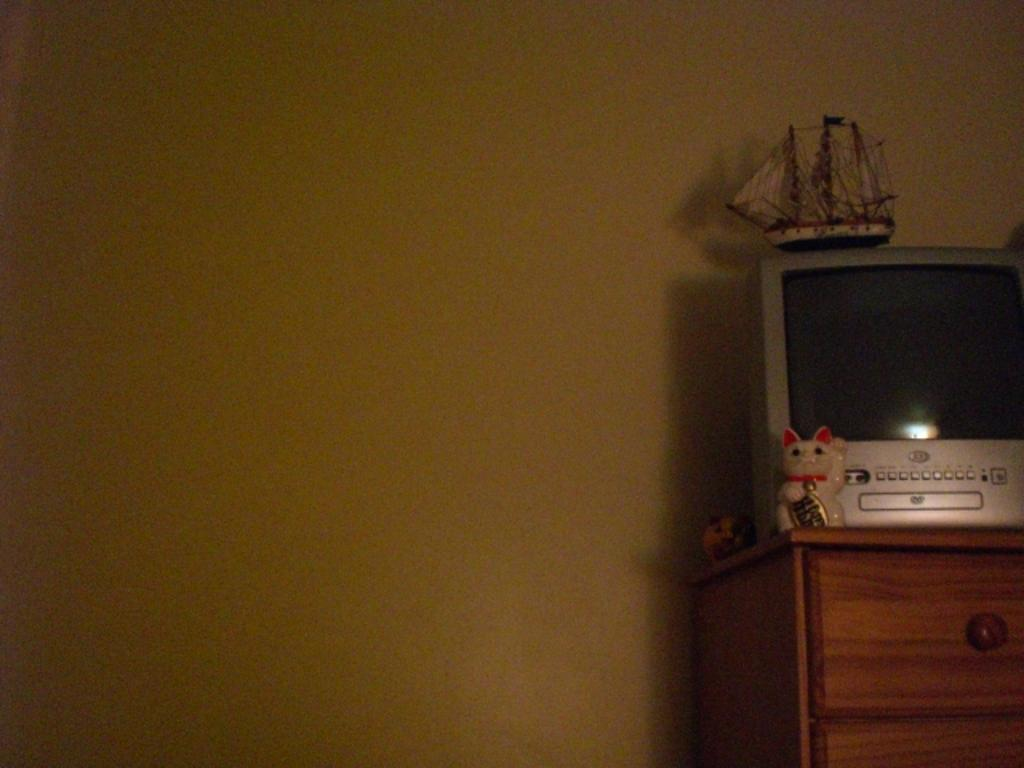What is the main object in the image? There is a television in the image. Where is the television located? The television is placed on a table. Can you describe the position of the table in the image? The table is in the right corner of the image. What else can be seen on the table? There are other objects on the table. What color is the background wall in the image? The background wall is yellow. How many friends are observing the television quietly in the image? There is no indication of friends or quiet observation in the image; it only shows a television placed on a table in the right corner of the room. 